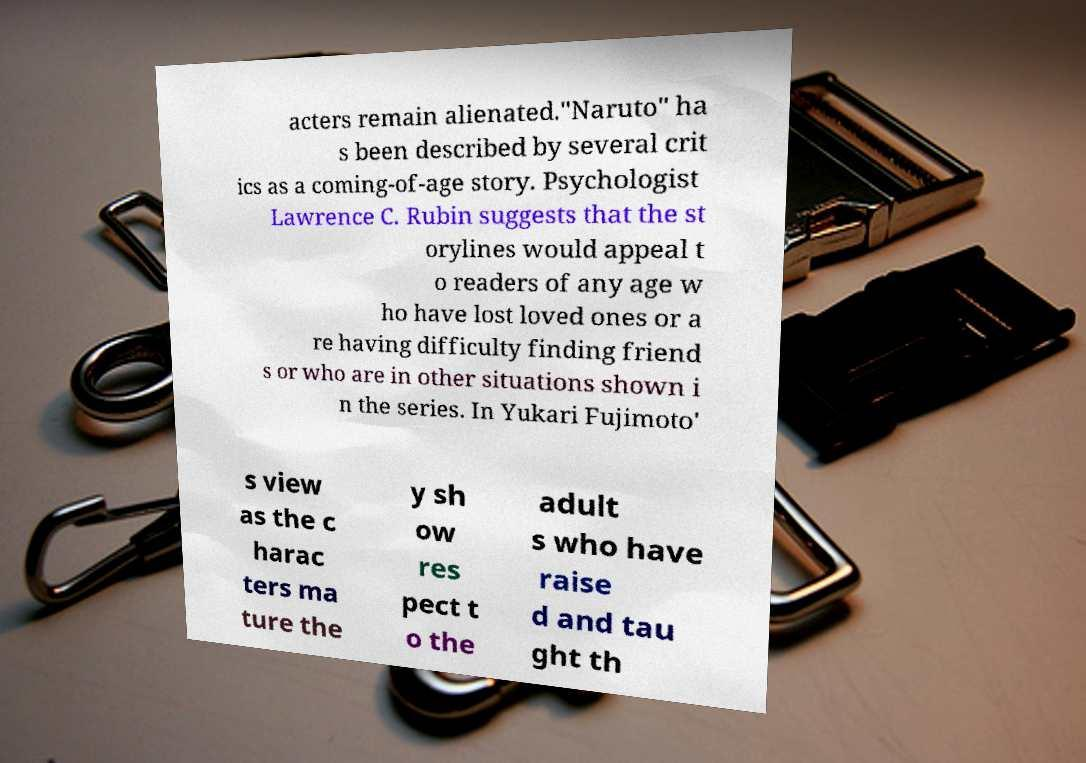Can you accurately transcribe the text from the provided image for me? acters remain alienated."Naruto" ha s been described by several crit ics as a coming-of-age story. Psychologist Lawrence C. Rubin suggests that the st orylines would appeal t o readers of any age w ho have lost loved ones or a re having difficulty finding friend s or who are in other situations shown i n the series. In Yukari Fujimoto' s view as the c harac ters ma ture the y sh ow res pect t o the adult s who have raise d and tau ght th 